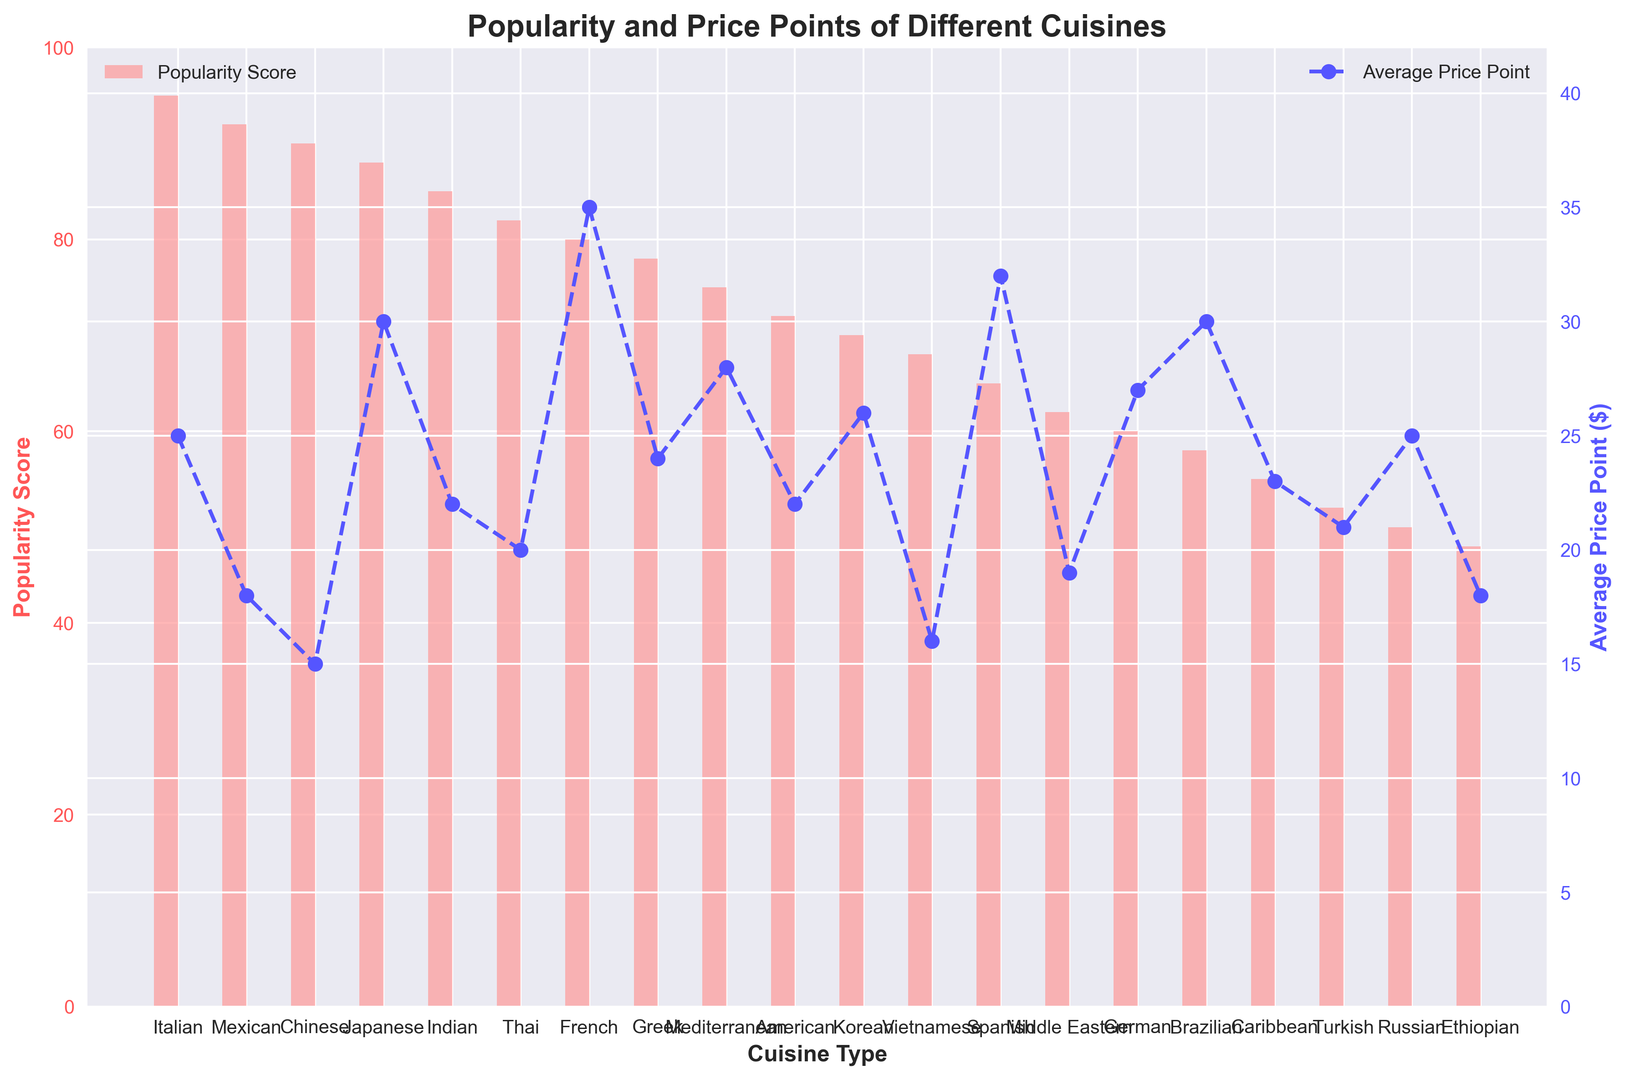What is the average price point of the most popular cuisine? The most popular cuisine in the chart is Italian, with a popularity score of 95. According to the plot, the average price point of Italian cuisine is $25.
Answer: $25 Which cuisine type has the highest average price point? Observing the values on the secondary axis (right y-axis) and the blue line representing the average price points, one can see that French cuisine has the highest average price point of $35.
Answer: French What is the difference in average price points between the least popular and most popular cuisines? The least popular cuisine is Ethiopian with a popularity score of 48, and its average price point is $18. The most popular cuisine, Italian, has an average price point of $25. The difference is $25 - $18 = $7.
Answer: $7 Which cuisine has the same price point as the least popular cuisine? The least popular cuisine, Ethiopian, has a price point of $18. By checking the values and plotting line, we find that Mexican cuisine also has an average price point of $18.
Answer: Mexican What is the median average price point among the listed cuisines? Listing the average price points in ascending order: 15, 16, 18, 18, 19, 20, 21, 22, 22, 23, 24, 25, 25, 26, 27, 28, 30, 30, 32, 35. With 20 values, the middle two values are the 10th and 11th: 22 and 23. The median is the average of these two values, (22 + 23) / 2 = 22.5.
Answer: 22.5 Is French cuisine more popular or less expensive than Japanese cuisine? French cuisine has a popularity score of 80 and an average price point of $35. Japanese cuisine has a popularity score of 88 and an average price point of $30. French cuisine is less popular and more expensive than Japanese cuisine.
Answer: Less popular and more expensive Which cuisine has a higher popularity score, Greek or Mediterranean? According to the figure, Greek cuisine has a popularity score of 78, while Mediterranean cuisine has a score of 75. Therefore, Greek cuisine has a higher popularity score.
Answer: Greek What is the average popularity score for cuisines with an average price point above $25? Cuisines with average price points above $25 are French (80), Mediterranean (75), Korean (70), German (60), Spanish (65), Brazilian (58). Summing their popularity scores: 80 + 75 + 70 + 60 + 65 + 58 = 408. Counting these cuisines, there are 6. The average is 408 / 6 = 68.
Answer: 68 Which is more popular, American cuisine or Thai cuisine? From the figure, American cuisine has a popularity score of 72, and Thai cuisine has a score of 82. Therefore, Thai cuisine is more popular.
Answer: Thai What is the combined popularity score of cuisines with popularity scores above 90? The cuisines with popularity scores above 90 are Italian (95), Mexican (92), and Chinese (90) (since 90 is included). The combined score is 95 + 92 + 90 = 277.
Answer: 277 